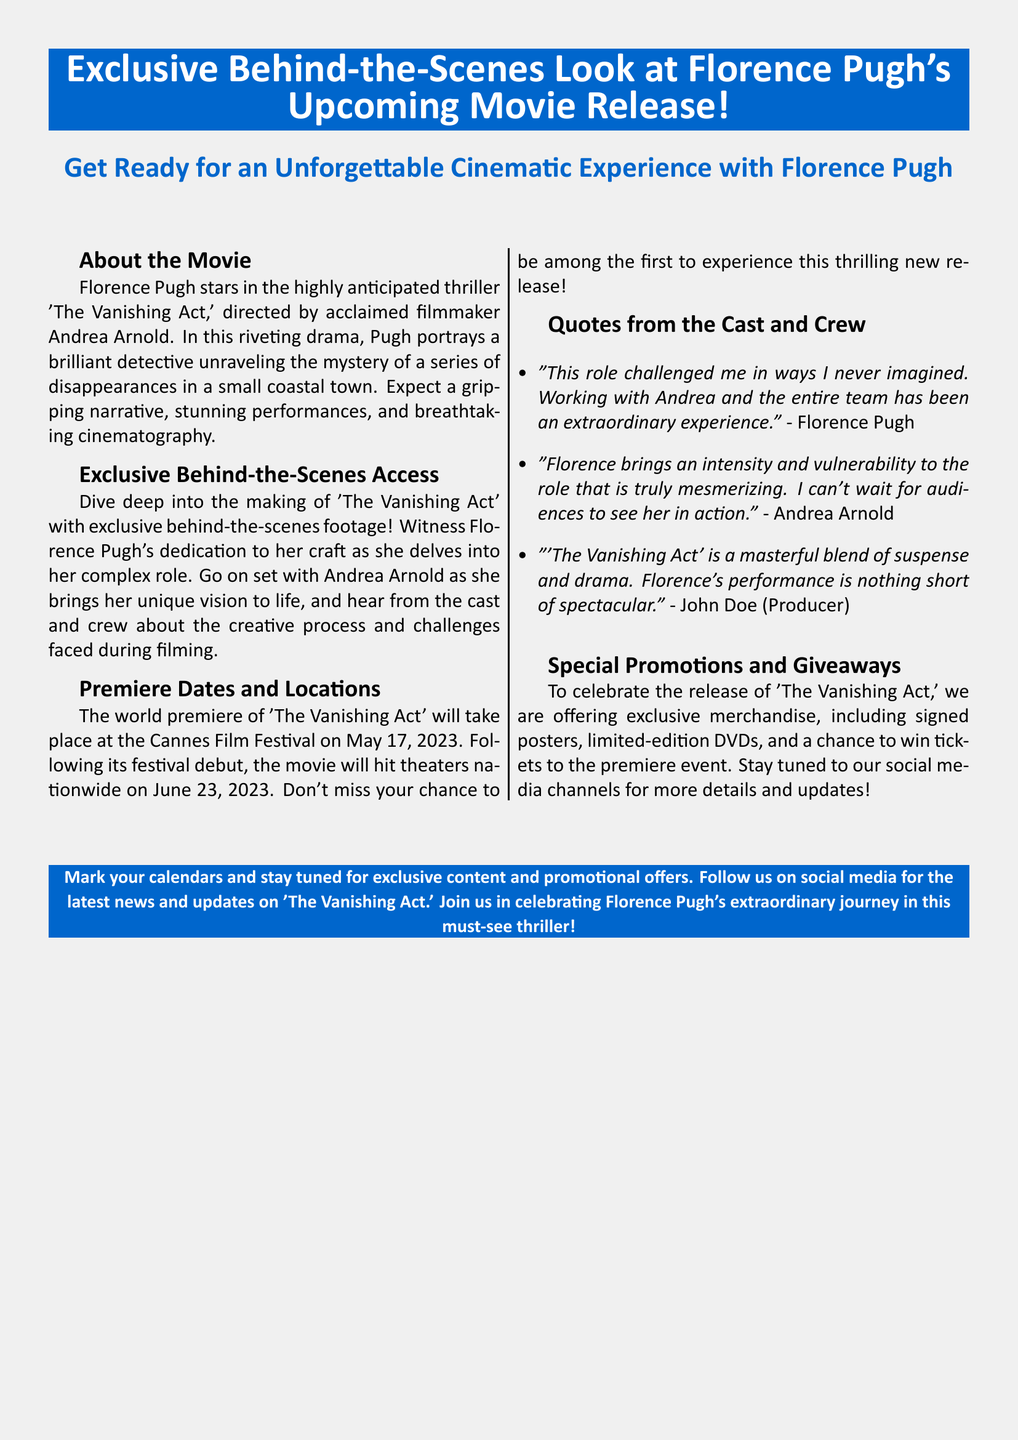What is the title of the movie? The title of the movie is mentioned directly in the document under the "About the Movie" section.
Answer: The Vanishing Act Who is the director of the movie? The director's name is specifically provided in the "About the Movie" section.
Answer: Andrea Arnold When is the world premiere scheduled? The premiere date is specifically stated in the "Premiere Dates and Locations" section.
Answer: May 17, 2023 What type of film is 'The Vanishing Act'? The genre is identified in the description of the movie.
Answer: Thriller What special promotions are mentioned? The document lists specific promotions in the "Special Promotions and Giveaways" section.
Answer: Exclusive merchandise Which festival will host the world premiere? The name of the festival is specified in the "Premiere Dates and Locations" section.
Answer: Cannes Film Festival What does Florence Pugh describe her role as? Her description is given in one of the quotes from the "Quotes from the Cast and Crew" section.
Answer: Challenging When will the movie be released in theaters? The release date is mentioned in the "Premiere Dates and Locations" section of the document.
Answer: June 23, 2023 What can fans win by following social media channels? The document specifies the prizes in the "Special Promotions and Giveaways" section.
Answer: Tickets to the premiere event 